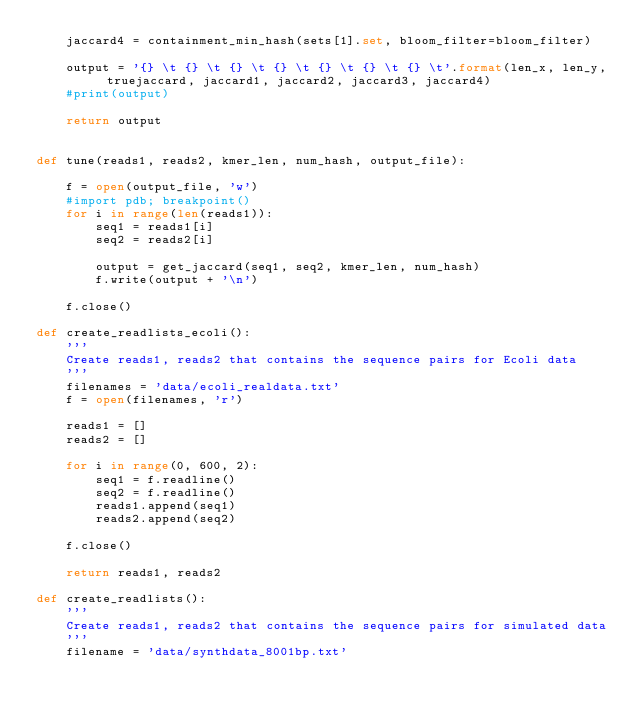Convert code to text. <code><loc_0><loc_0><loc_500><loc_500><_Python_>	jaccard4 = containment_min_hash(sets[1].set, bloom_filter=bloom_filter)

	output = '{} \t {} \t {} \t {} \t {} \t {} \t {} \t'.format(len_x, len_y, truejaccard, jaccard1, jaccard2, jaccard3, jaccard4)
	#print(output)

	return output


def tune(reads1, reads2, kmer_len, num_hash, output_file):

	f = open(output_file, 'w')
	#import pdb; breakpoint()
	for i in range(len(reads1)):
		seq1 = reads1[i]
		seq2 = reads2[i]

		output = get_jaccard(seq1, seq2, kmer_len, num_hash)		
		f.write(output + '\n')

	f.close()

def create_readlists_ecoli():
	'''
	Create reads1, reads2 that contains the sequence pairs for Ecoli data
	'''
	filenames = 'data/ecoli_realdata.txt'
	f = open(filenames, 'r')

	reads1 = []
	reads2 = []

	for i in range(0, 600, 2):
		seq1 = f.readline()
		seq2 = f.readline()
		reads1.append(seq1)
		reads2.append(seq2)

	f.close()
		
	return reads1, reads2

def create_readlists():
	'''
	Create reads1, reads2 that contains the sequence pairs for simulated data
	'''
	filename = 'data/synthdata_8001bp.txt'</code> 